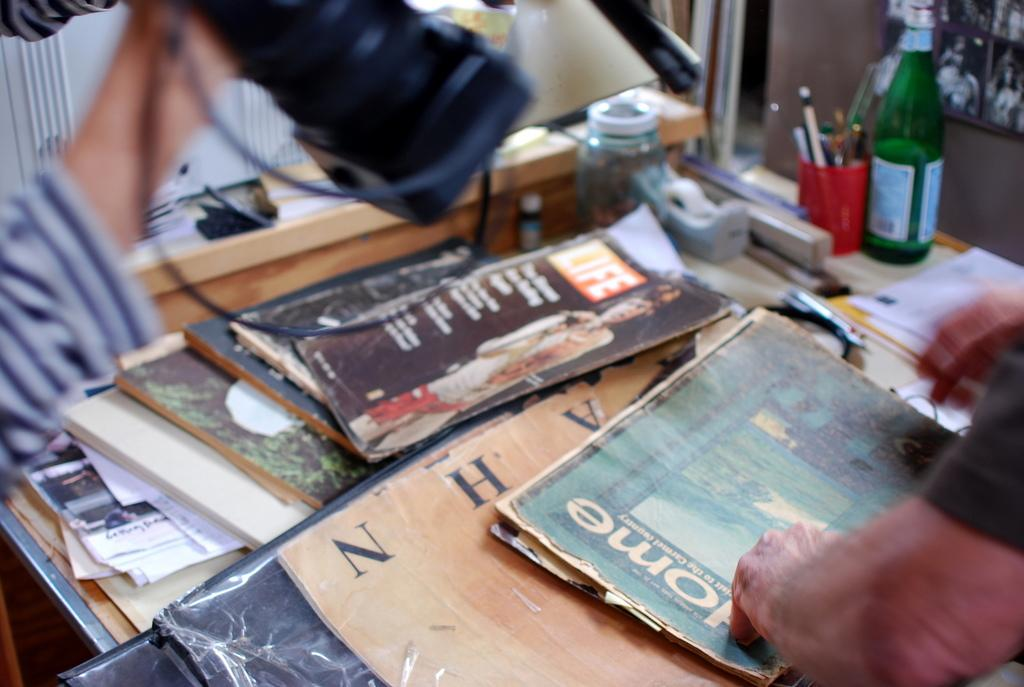<image>
Offer a succinct explanation of the picture presented. various vintage magazines that includes home and life 